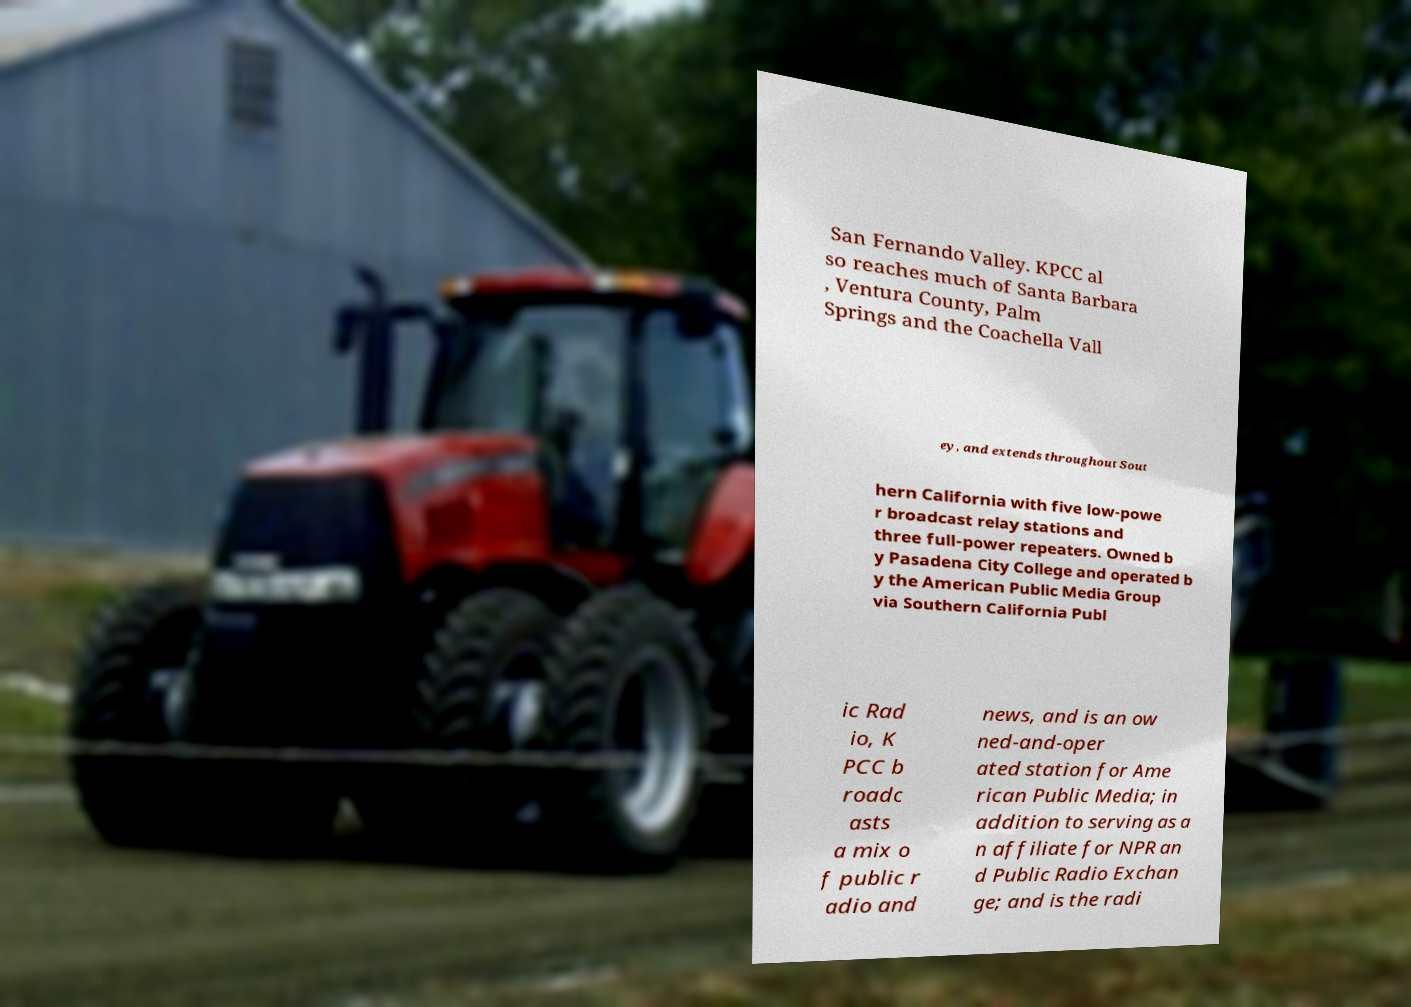Please read and relay the text visible in this image. What does it say? San Fernando Valley. KPCC al so reaches much of Santa Barbara , Ventura County, Palm Springs and the Coachella Vall ey, and extends throughout Sout hern California with five low-powe r broadcast relay stations and three full-power repeaters. Owned b y Pasadena City College and operated b y the American Public Media Group via Southern California Publ ic Rad io, K PCC b roadc asts a mix o f public r adio and news, and is an ow ned-and-oper ated station for Ame rican Public Media; in addition to serving as a n affiliate for NPR an d Public Radio Exchan ge; and is the radi 